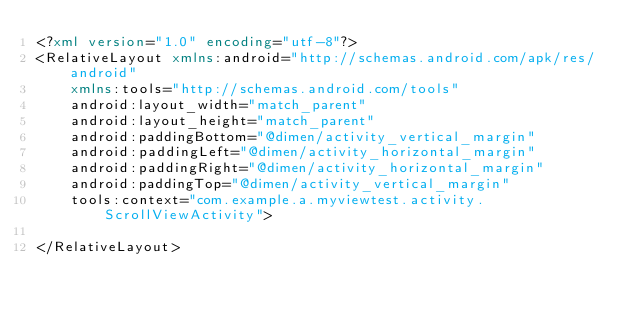<code> <loc_0><loc_0><loc_500><loc_500><_XML_><?xml version="1.0" encoding="utf-8"?>
<RelativeLayout xmlns:android="http://schemas.android.com/apk/res/android"
    xmlns:tools="http://schemas.android.com/tools"
    android:layout_width="match_parent"
    android:layout_height="match_parent"
    android:paddingBottom="@dimen/activity_vertical_margin"
    android:paddingLeft="@dimen/activity_horizontal_margin"
    android:paddingRight="@dimen/activity_horizontal_margin"
    android:paddingTop="@dimen/activity_vertical_margin"
    tools:context="com.example.a.myviewtest.activity.ScrollViewActivity">

</RelativeLayout>
</code> 